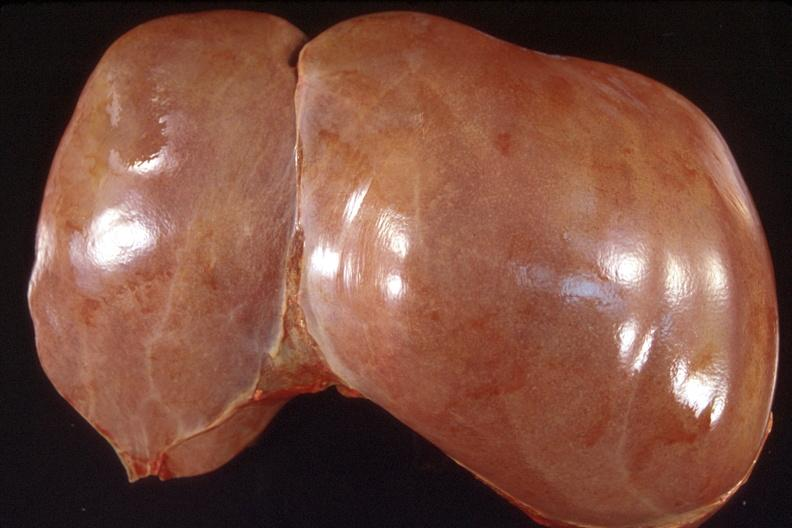does hematoma show liver, normal?
Answer the question using a single word or phrase. No 